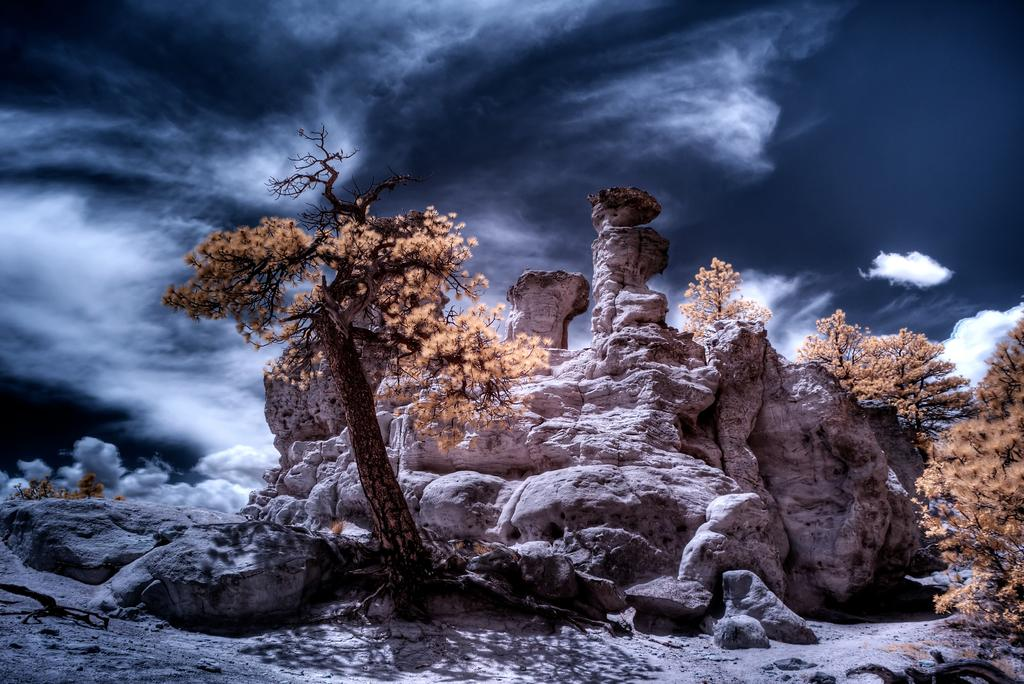What type of vegetation is visible in the front of the image? There are trees in the front of the image. What can be seen in the background of the image? There are clouds and the sky visible in the background of the image. What type of vein is visible in the image? There is no vein present in the image; it features trees in the front and clouds and sky in the background. What direction does the society face in the image? There is no society present in the image, only trees, clouds, and sky. 